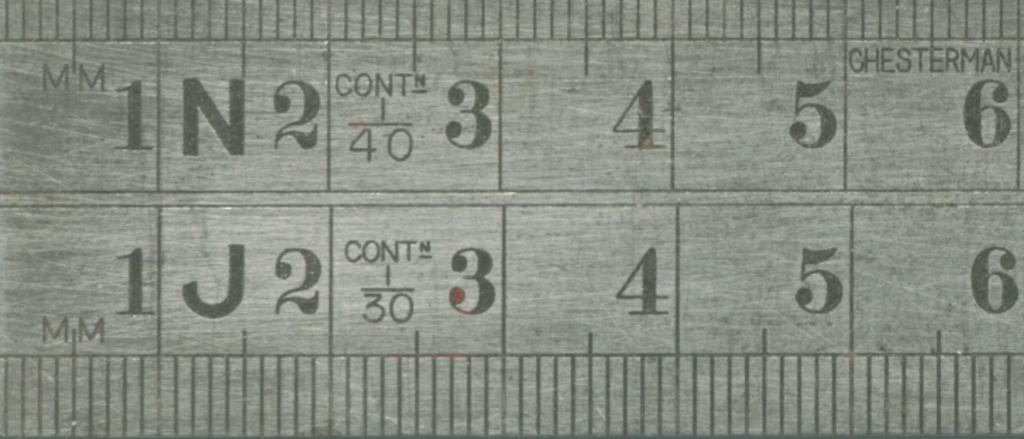<image>
Give a short and clear explanation of the subsequent image. A ruler made by Chesterman shows numbers 1 through 6 